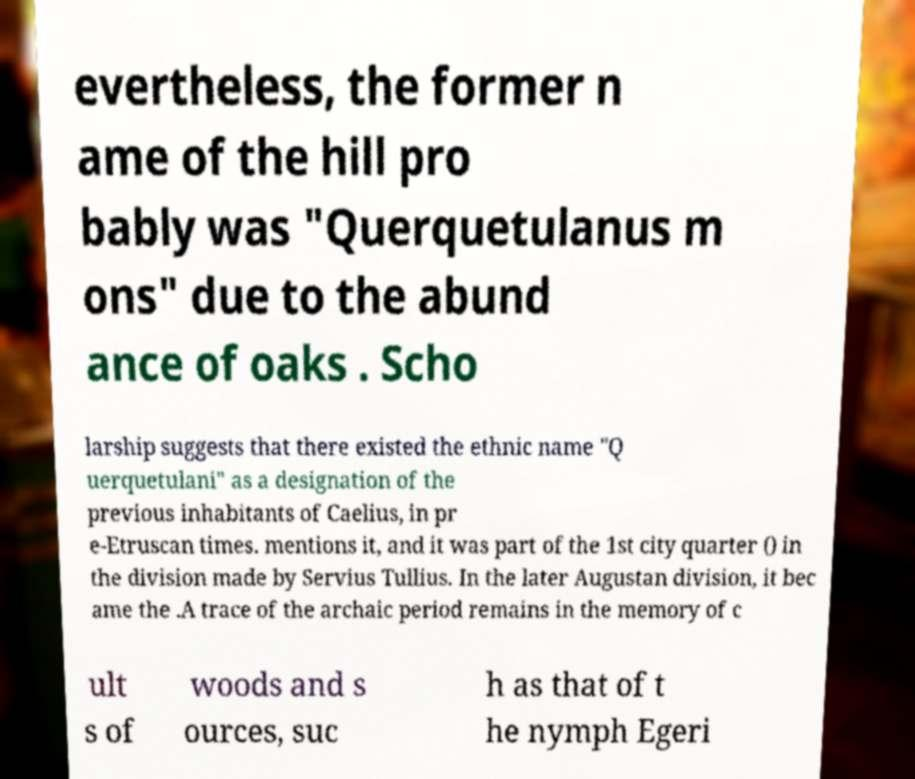Can you accurately transcribe the text from the provided image for me? evertheless, the former n ame of the hill pro bably was "Querquetulanus m ons" due to the abund ance of oaks . Scho larship suggests that there existed the ethnic name "Q uerquetulani" as a designation of the previous inhabitants of Caelius, in pr e-Etruscan times. mentions it, and it was part of the 1st city quarter () in the division made by Servius Tullius. In the later Augustan division, it bec ame the .A trace of the archaic period remains in the memory of c ult s of woods and s ources, suc h as that of t he nymph Egeri 